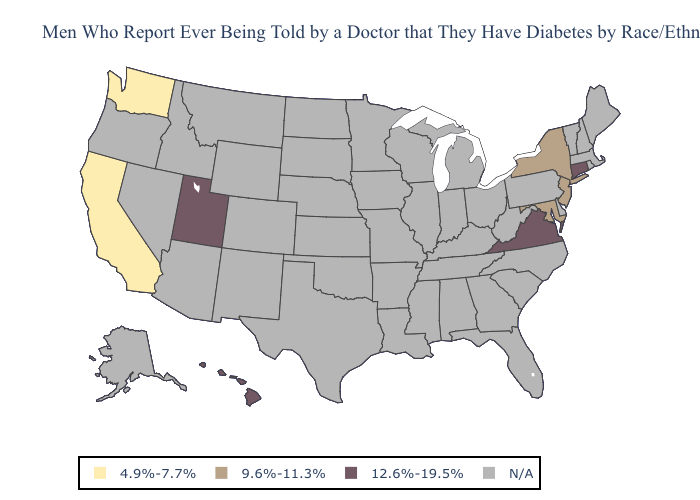What is the highest value in states that border Rhode Island?
Quick response, please. 12.6%-19.5%. Does Hawaii have the highest value in the USA?
Give a very brief answer. Yes. Does Maryland have the lowest value in the South?
Keep it brief. Yes. Which states have the lowest value in the West?
Be succinct. California, Washington. Which states have the highest value in the USA?
Answer briefly. Connecticut, Hawaii, Utah, Virginia. Name the states that have a value in the range 9.6%-11.3%?
Answer briefly. Maryland, New Jersey, New York. Does Washington have the highest value in the USA?
Short answer required. No. Which states have the highest value in the USA?
Give a very brief answer. Connecticut, Hawaii, Utah, Virginia. How many symbols are there in the legend?
Keep it brief. 4. Name the states that have a value in the range 4.9%-7.7%?
Concise answer only. California, Washington. 